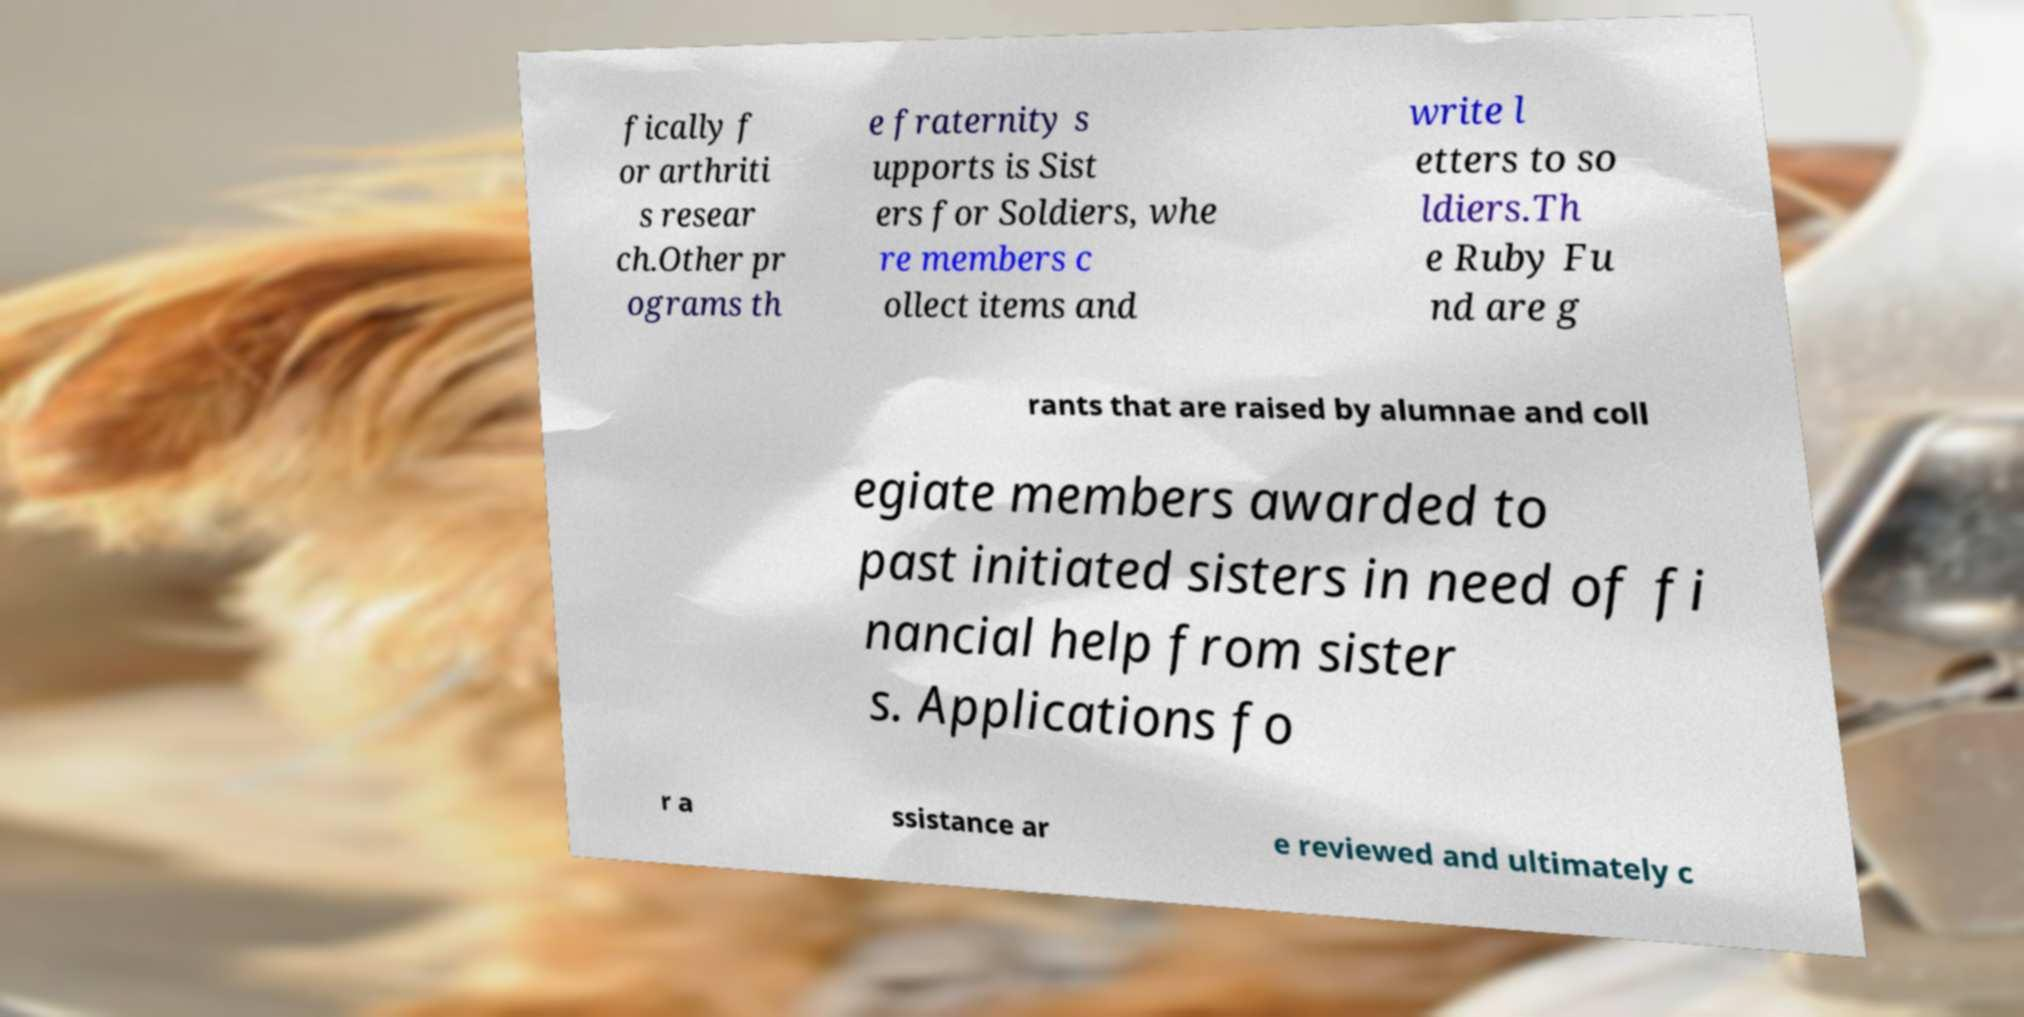Can you read and provide the text displayed in the image?This photo seems to have some interesting text. Can you extract and type it out for me? fically f or arthriti s resear ch.Other pr ograms th e fraternity s upports is Sist ers for Soldiers, whe re members c ollect items and write l etters to so ldiers.Th e Ruby Fu nd are g rants that are raised by alumnae and coll egiate members awarded to past initiated sisters in need of fi nancial help from sister s. Applications fo r a ssistance ar e reviewed and ultimately c 